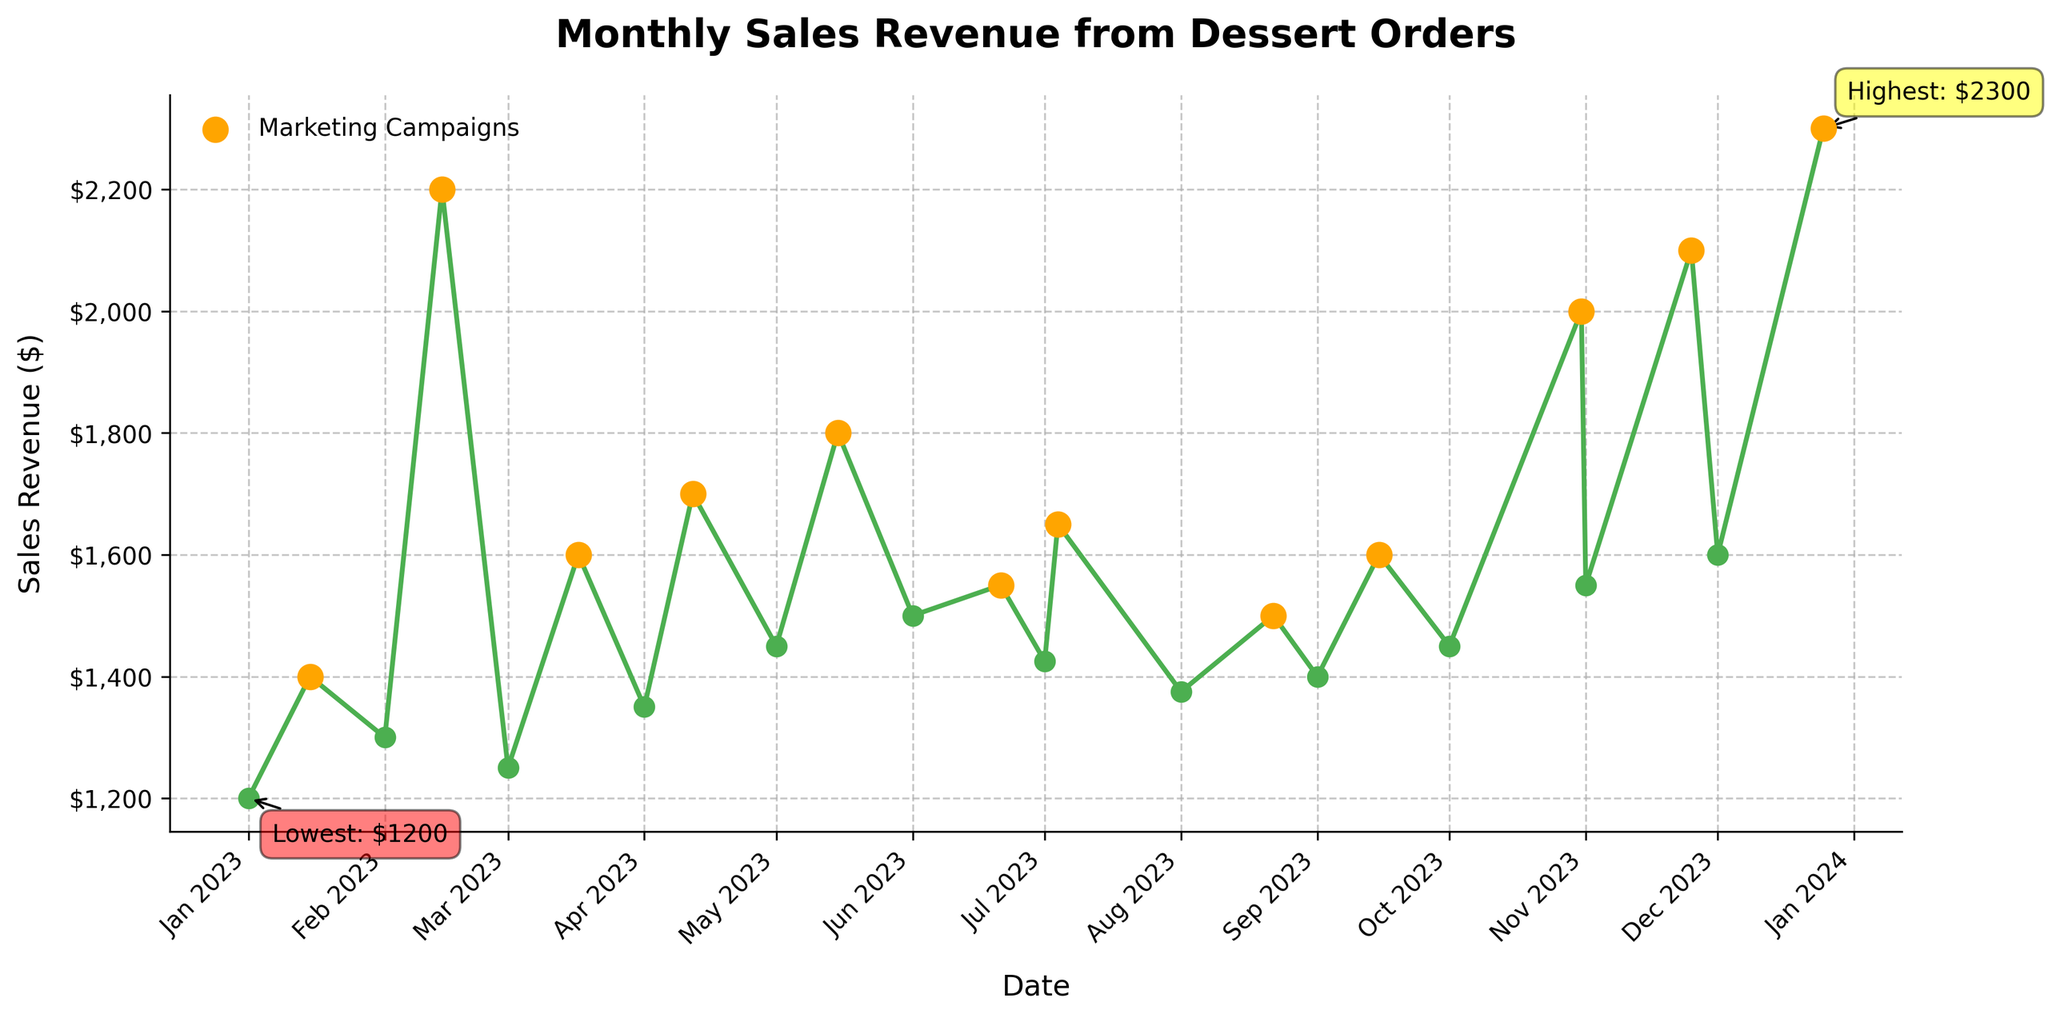What's the title of the plot? The title of the plot is written at the top center and provides a brief description of the data.
Answer: Monthly Sales Revenue from Dessert Orders What is the highest sales revenue recorded? Look for the highest point on the plot marked with the annotation "Highest: $2300" and identify its value.
Answer: $2300 What is the lowest sales revenue recorded, and when did it occur? Locate the lowest point on the plot marked with the annotation "Lowest: $1200" and note its value and the corresponding date below the x-axis.
Answer: $1200 on 2023-01-01 How many marketing campaigns are highlighted in the plot? Count the number of points marked with a distinct color (orange) on the plot.
Answer: 12 Which month shows the highest sales revenue, and is there a marketing campaign associated with it? Identify the point with the highest sales revenue ($2300) and check its corresponding date (December 25), then see if there is a campaign mark.
Answer: December 25, Christmas Special What's the difference in sales revenue between the Valentine's Day Special and the Black Friday Deals? Locate the sales revenue points for February 14 ($2200) and November 25 ($2100), then subtract the latter from the former.
Answer: $100 In which month did the sales revenue increase the most compared to the previous month, and by how much? Examine each month's revenue and calculate the differences, then identify the largest positive difference.
Answer: February by $900 Compare the sales revenue on Valentine's Day Special and St. Patrick's Day Discount. Which one had higher sales? Identify the sales revenue for February 14 ($2200) and March 17 ($1600), then compare the two values.
Answer: Valentine's Day Special Which marketing campaign resulted in the lowest sales revenue, and what was that revenue? Look for the point with the lowest sales revenue among the highlighted campaigns, noting both the campaign and its value.
Answer: Start of Summer Sale, $1550 By what percentage did the sales revenue increase from the lowest point to the highest point? Calculate the percentage increase using the formula [(2300 - 1200) / 1200] * 100%.
Answer: 91.67% 